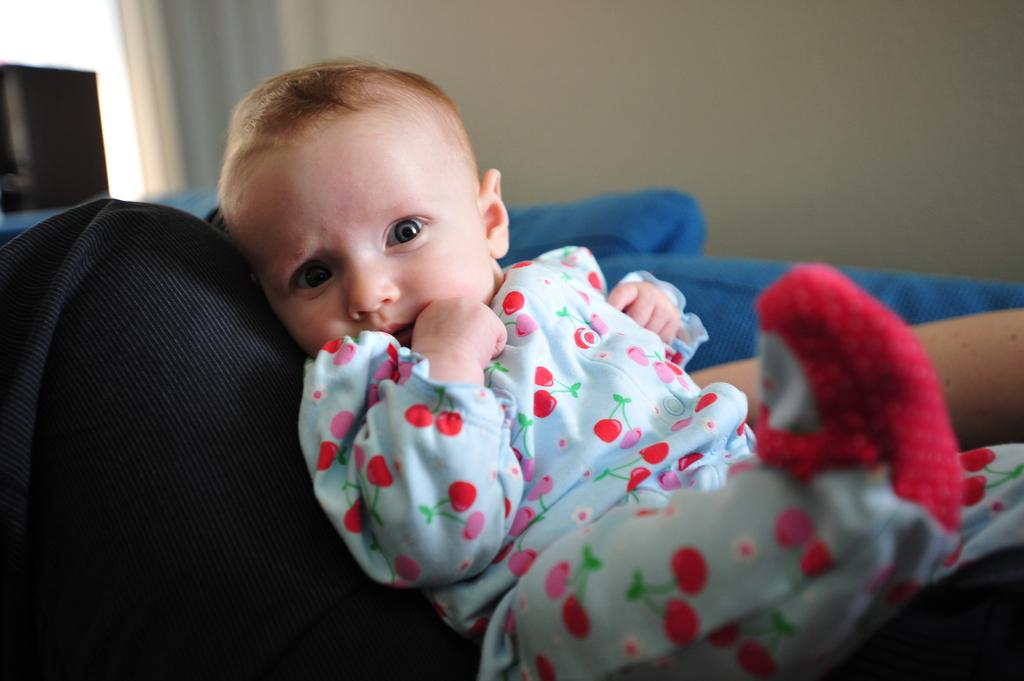What is the main subject of the image? There is a baby in the image. What is the baby sitting on? The baby is sitting on an object. What colors can be seen in the background of the image? There is a blue color bed sheet and a white wall in the background. What type of fear can be seen on the baby's face in the image? There is no indication of fear on the baby's face in the image. Is there a fire visible in the image? No, there is no fire present in the image. Can you see a pipe in the image? There is no pipe visible in the image. 